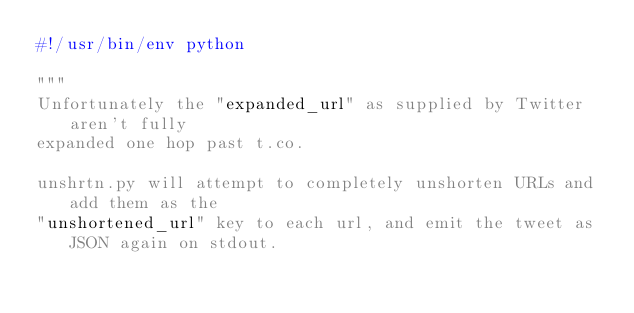<code> <loc_0><loc_0><loc_500><loc_500><_Python_>#!/usr/bin/env python

"""
Unfortunately the "expanded_url" as supplied by Twitter aren't fully
expanded one hop past t.co.

unshrtn.py will attempt to completely unshorten URLs and add them as the
"unshortened_url" key to each url, and emit the tweet as JSON again on stdout.
</code> 